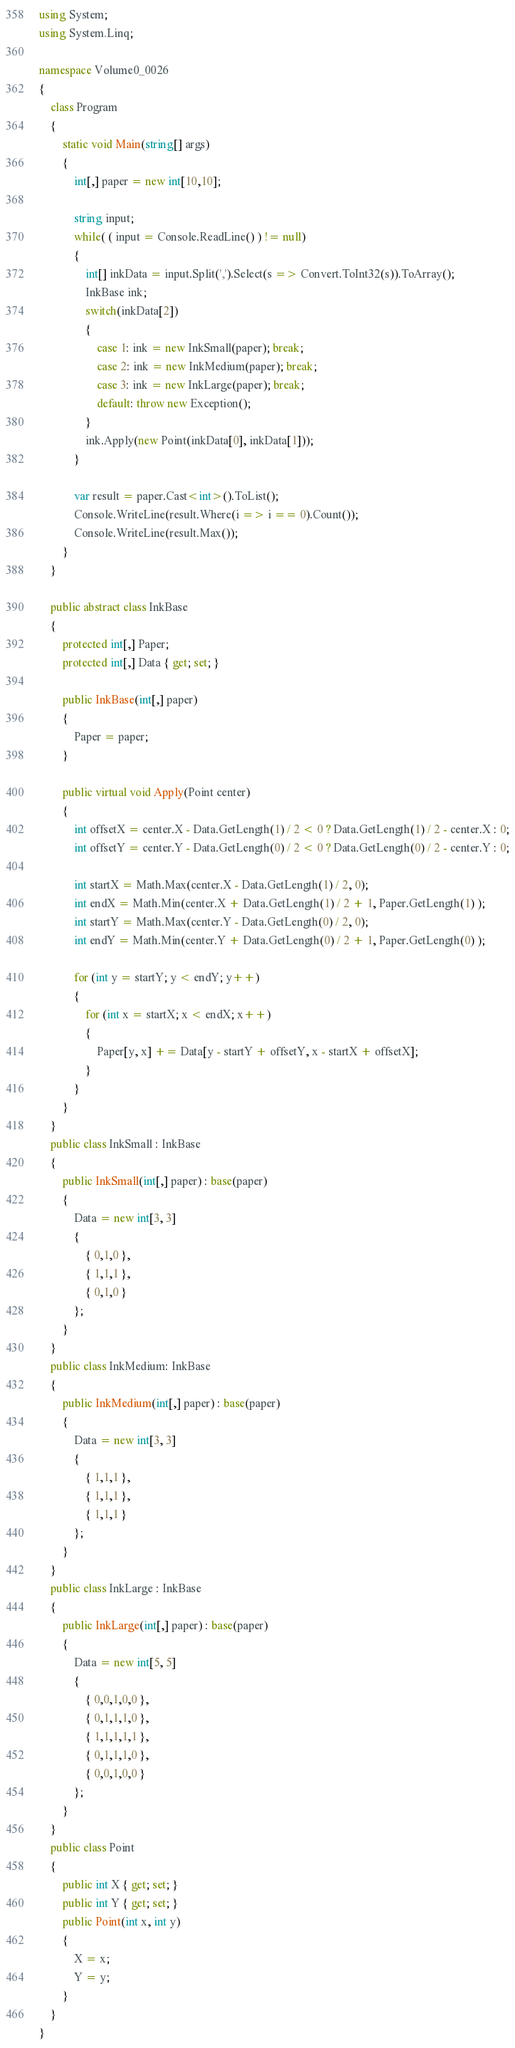Convert code to text. <code><loc_0><loc_0><loc_500><loc_500><_C#_>using System;
using System.Linq;

namespace Volume0_0026
{
    class Program
    {
        static void Main(string[] args)
        {
            int[,] paper = new int[10,10];

            string input;
            while( ( input = Console.ReadLine() ) != null)
            {
                int[] inkData = input.Split(',').Select(s => Convert.ToInt32(s)).ToArray();
                InkBase ink;
                switch(inkData[2])
                {
                    case 1: ink = new InkSmall(paper); break;
                    case 2: ink = new InkMedium(paper); break;
                    case 3: ink = new InkLarge(paper); break;
                    default: throw new Exception();
                }
                ink.Apply(new Point(inkData[0], inkData[1]));
            }

            var result = paper.Cast<int>().ToList();
            Console.WriteLine(result.Where(i => i == 0).Count());
            Console.WriteLine(result.Max());
        }
    }

    public abstract class InkBase
    {
        protected int[,] Paper;
        protected int[,] Data { get; set; }

        public InkBase(int[,] paper)
        {
            Paper = paper;
        }

        public virtual void Apply(Point center)
        {
            int offsetX = center.X - Data.GetLength(1) / 2 < 0 ? Data.GetLength(1) / 2 - center.X : 0;
            int offsetY = center.Y - Data.GetLength(0) / 2 < 0 ? Data.GetLength(0) / 2 - center.Y : 0;

            int startX = Math.Max(center.X - Data.GetLength(1) / 2, 0);
            int endX = Math.Min(center.X + Data.GetLength(1) / 2 + 1, Paper.GetLength(1) );
            int startY = Math.Max(center.Y - Data.GetLength(0) / 2, 0);
            int endY = Math.Min(center.Y + Data.GetLength(0) / 2 + 1, Paper.GetLength(0) );

            for (int y = startY; y < endY; y++)
            {
                for (int x = startX; x < endX; x++)
                {
                    Paper[y, x] += Data[y - startY + offsetY, x - startX + offsetX];
                }
            }
        }
    }
    public class InkSmall : InkBase
    {
        public InkSmall(int[,] paper) : base(paper)
        {
            Data = new int[3, 3]
            {
                { 0,1,0 },
                { 1,1,1 },
                { 0,1,0 }
            };
        }
    }
    public class InkMedium: InkBase
    {
        public InkMedium(int[,] paper) : base(paper)
        {
            Data = new int[3, 3]
            {
                { 1,1,1 },
                { 1,1,1 },
                { 1,1,1 }
            };
        }
    }
    public class InkLarge : InkBase
    {
        public InkLarge(int[,] paper) : base(paper)
        {
            Data = new int[5, 5]
            {
                { 0,0,1,0,0 },
                { 0,1,1,1,0 },
                { 1,1,1,1,1 },
                { 0,1,1,1,0 },
                { 0,0,1,0,0 }
            };
        }
    }
    public class Point
    {
        public int X { get; set; }
        public int Y { get; set; }
        public Point(int x, int y)
        {
            X = x;
            Y = y;
        }
    }
}</code> 